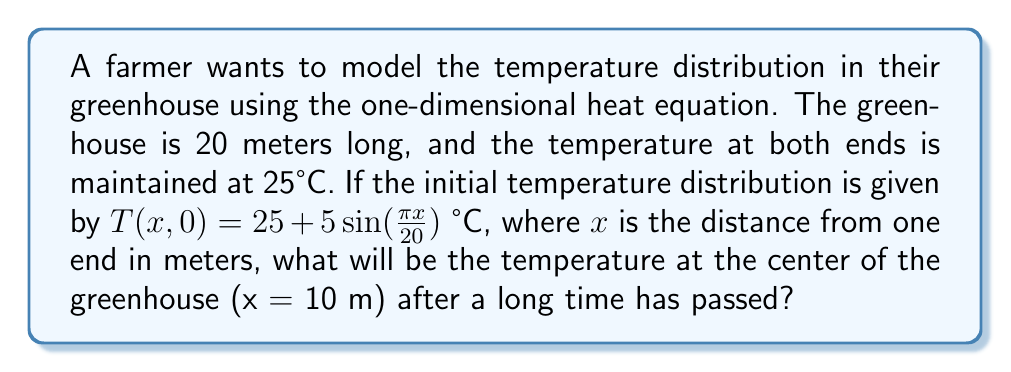Can you solve this math problem? Let's approach this step-by-step:

1) The one-dimensional heat equation is given by:

   $$\frac{\partial T}{\partial t} = k\frac{\partial^2 T}{\partial x^2}$$

   where $T$ is temperature, $t$ is time, $x$ is position, and $k$ is the thermal diffusivity.

2) The boundary conditions are:
   $T(0,t) = T(20,t) = 25$ °C for all $t$

3) The initial condition is:
   $T(x,0) = 25 + 5\sin(\frac{\pi x}{20})$ °C

4) For the steady-state solution (after a long time), we set $\frac{\partial T}{\partial t} = 0$. This gives:

   $$0 = k\frac{\partial^2 T}{\partial x^2}$$

5) The general solution to this equation is:
   
   $T(x) = Ax + B$

   where $A$ and $B$ are constants determined by the boundary conditions.

6) Applying the boundary conditions:
   
   At $x = 0$: $25 = B$
   At $x = 20$: $25 = 20A + B$

7) Solving these equations:
   
   $B = 25$
   $A = 0$

8) Therefore, the steady-state solution is:

   $T(x) = 25$ °C

9) This means that after a long time, the temperature throughout the greenhouse will be uniform at 25°C, regardless of the initial distribution.

10) At the center of the greenhouse (x = 10 m), the temperature will also be 25°C.
Answer: 25°C 